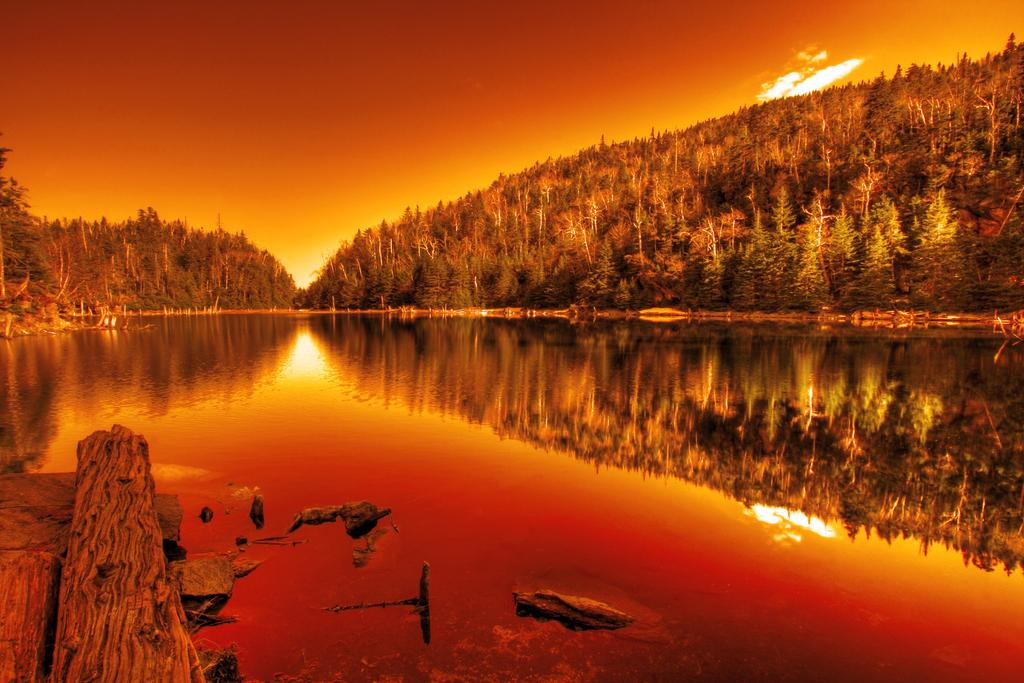What type of vegetation can be seen in the image? There are trees in the image. What natural element is present alongside the trees? There is water in the image. What type of ground surface is visible in the image? There are stones in the image. What can be seen in the water due to the presence of trees? Tree reflections are visible in the water. What is visible at the top of the image? The sky is visible at the top of the image. What type of creature can be seen flying over the trees in the image? There is no creature visible in the image; it only features trees, water, stones, tree reflections, and the sky. Is there a ghost visible in the image? There is no ghost present in the image. 